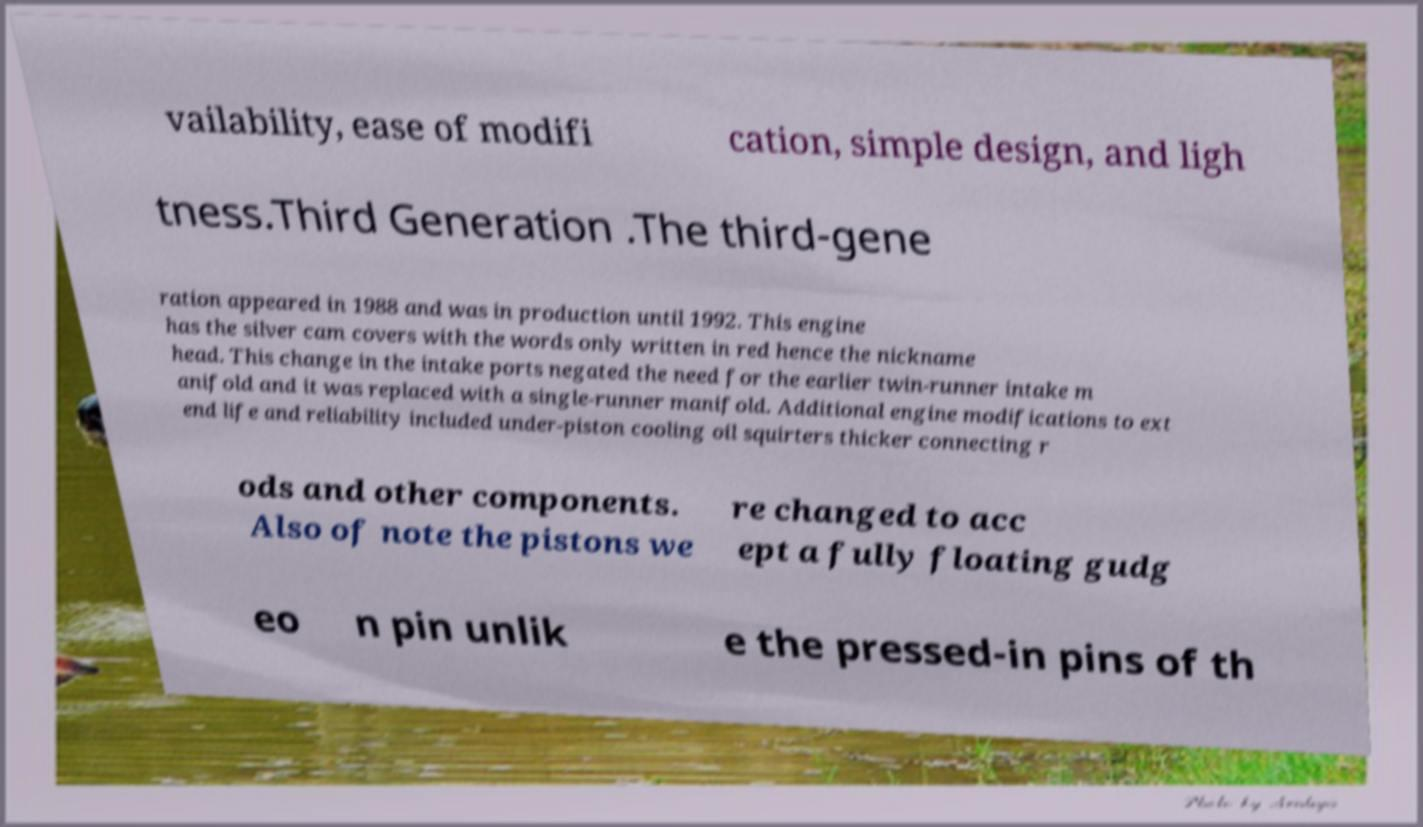What messages or text are displayed in this image? I need them in a readable, typed format. vailability, ease of modifi cation, simple design, and ligh tness.Third Generation .The third-gene ration appeared in 1988 and was in production until 1992. This engine has the silver cam covers with the words only written in red hence the nickname head. This change in the intake ports negated the need for the earlier twin-runner intake m anifold and it was replaced with a single-runner manifold. Additional engine modifications to ext end life and reliability included under-piston cooling oil squirters thicker connecting r ods and other components. Also of note the pistons we re changed to acc ept a fully floating gudg eo n pin unlik e the pressed-in pins of th 